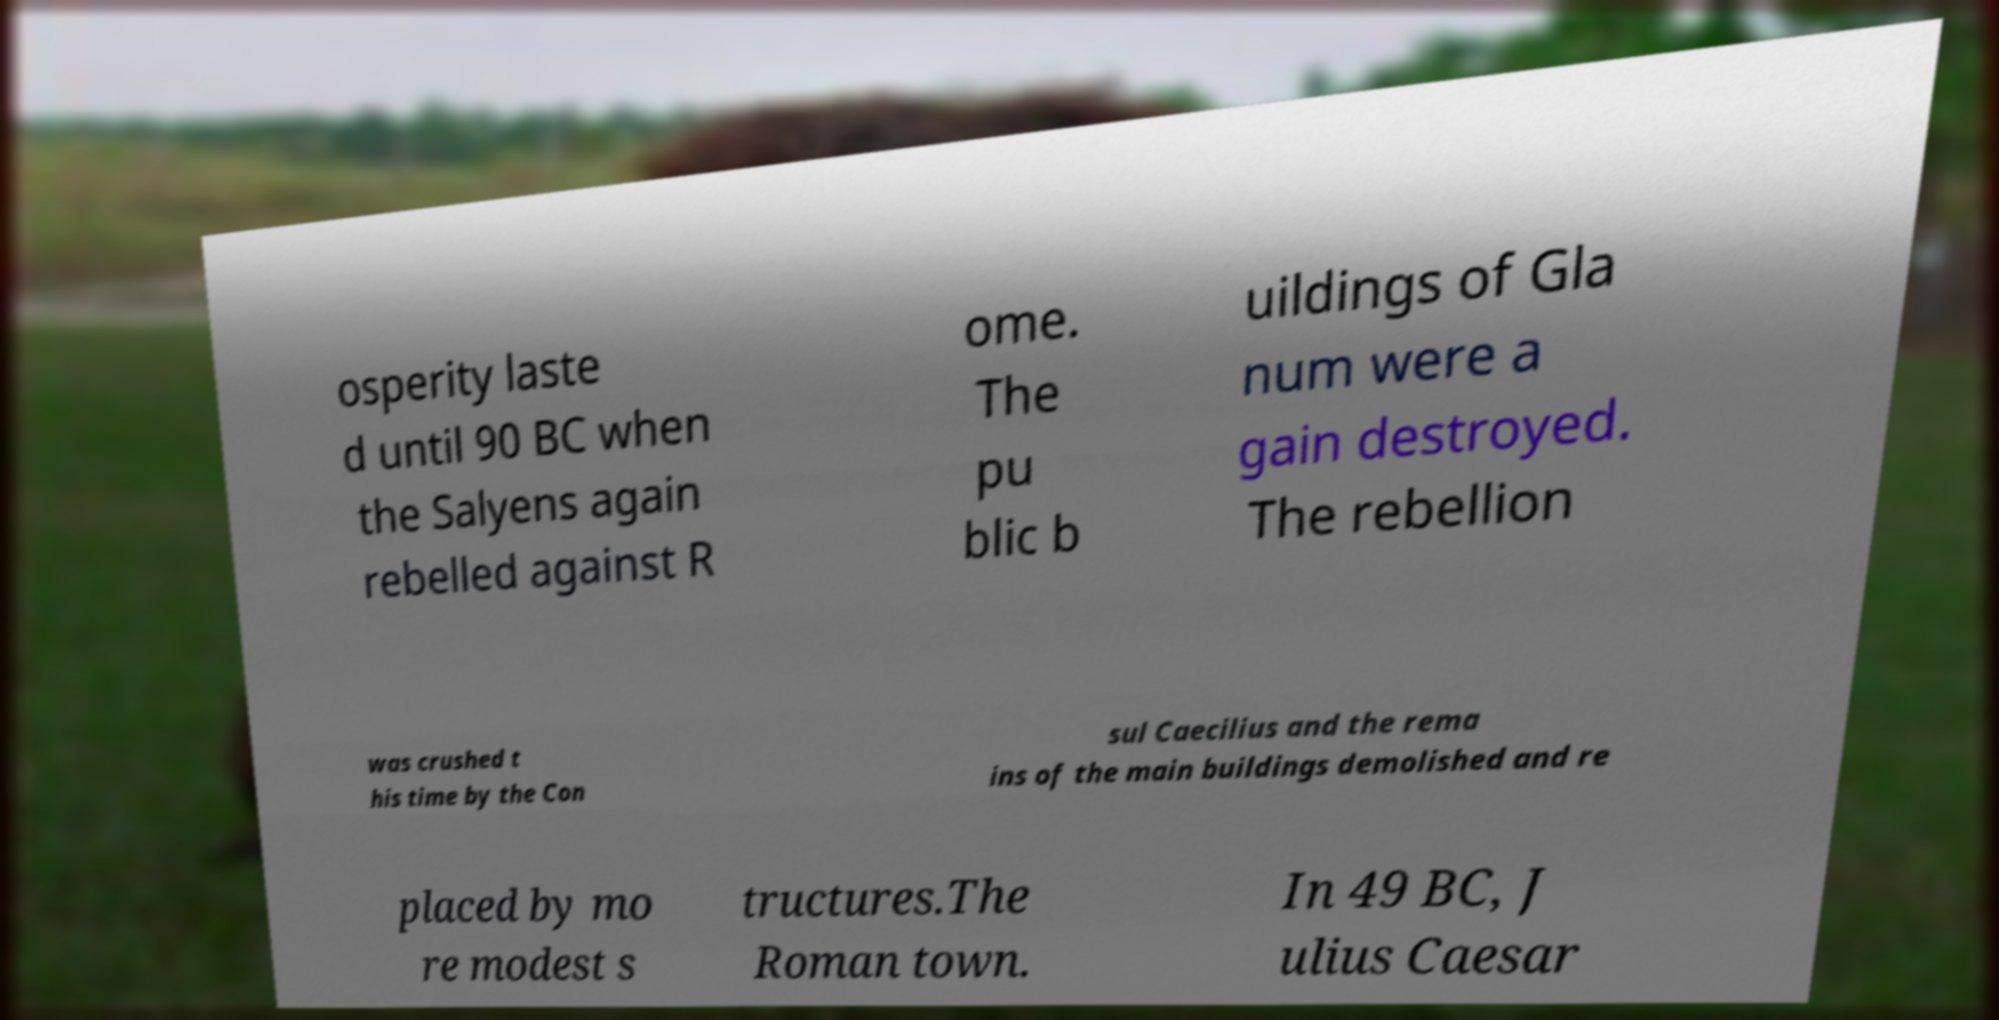There's text embedded in this image that I need extracted. Can you transcribe it verbatim? osperity laste d until 90 BC when the Salyens again rebelled against R ome. The pu blic b uildings of Gla num were a gain destroyed. The rebellion was crushed t his time by the Con sul Caecilius and the rema ins of the main buildings demolished and re placed by mo re modest s tructures.The Roman town. In 49 BC, J ulius Caesar 